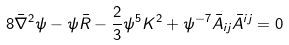<formula> <loc_0><loc_0><loc_500><loc_500>8 \bar { \nabla } ^ { 2 } \psi - \psi { \bar { R } } - \frac { 2 } { 3 } \psi ^ { 5 } K ^ { 2 } + \psi ^ { - 7 } \bar { A } _ { i j } \bar { A } ^ { i j } = 0</formula> 